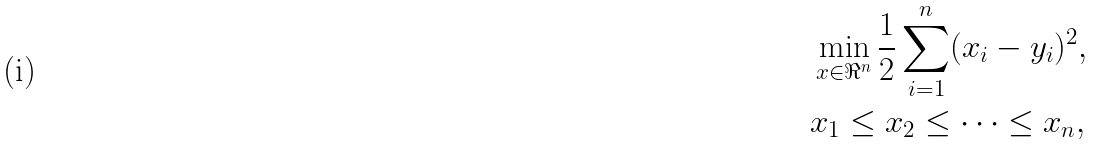Convert formula to latex. <formula><loc_0><loc_0><loc_500><loc_500>& \min _ { x \in \Re ^ { n } } \frac { 1 } { 2 } \sum _ { i = 1 } ^ { n } ( x _ { i } - y _ { i } ) ^ { 2 } , \\ & x _ { 1 } \leq x _ { 2 } \leq \dots \leq x _ { n } ,</formula> 